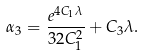Convert formula to latex. <formula><loc_0><loc_0><loc_500><loc_500>\alpha _ { 3 } = \frac { e ^ { 4 C _ { 1 } \lambda } } { 3 2 C _ { 1 } ^ { 2 } } + C _ { 3 } \lambda .</formula> 